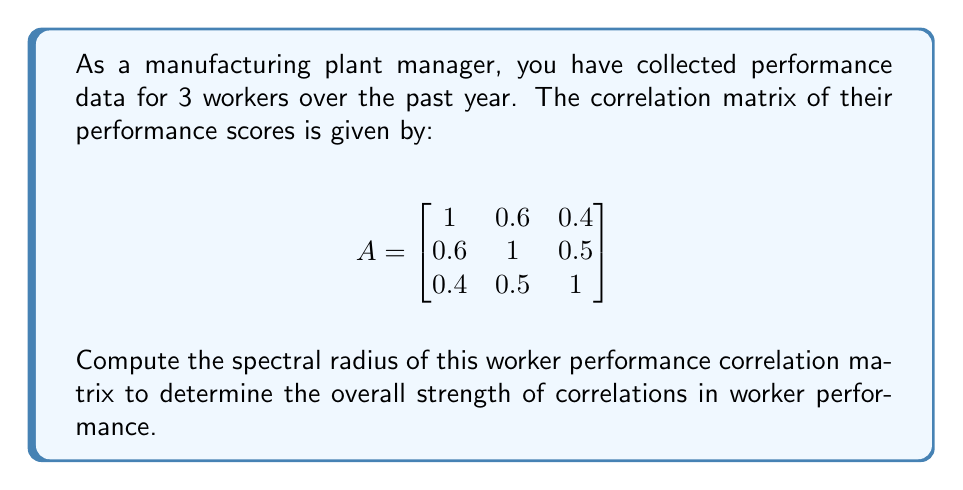Help me with this question. To compute the spectral radius of the correlation matrix A, we need to follow these steps:

1) First, recall that the spectral radius is the maximum absolute value of the eigenvalues of the matrix.

2) To find the eigenvalues, we need to solve the characteristic equation:
   $$\det(A - \lambda I) = 0$$

3) Expanding this determinant:
   $$\begin{vmatrix}
   1-\lambda & 0.6 & 0.4 \\
   0.6 & 1-\lambda & 0.5 \\
   0.4 & 0.5 & 1-\lambda
   \end{vmatrix} = 0$$

4) This expands to:
   $$(1-\lambda)^3 + 2(0.6)(0.5)(0.4) - (1-\lambda)[(0.6)^2 + (0.5)^2 + (0.4)^2] = 0$$

5) Simplifying:
   $$-\lambda^3 + 3\lambda^2 - 2.11\lambda + 0.456 = 0$$

6) This cubic equation can be solved using numerical methods. The three roots (eigenvalues) are approximately:
   $$\lambda_1 \approx 2.1523, \lambda_2 \approx 0.5238, \lambda_3 \approx 0.3239$$

7) The spectral radius is the maximum absolute value among these eigenvalues:
   $$\rho(A) = \max(|\lambda_1|, |\lambda_2|, |\lambda_3|) \approx 2.1523$$

Therefore, the spectral radius of the worker performance correlation matrix is approximately 2.1523.
Answer: $2.1523$ 